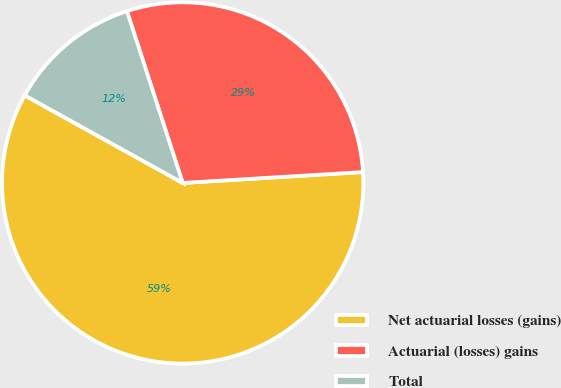Convert chart to OTSL. <chart><loc_0><loc_0><loc_500><loc_500><pie_chart><fcel>Net actuarial losses (gains)<fcel>Actuarial (losses) gains<fcel>Total<nl><fcel>59.02%<fcel>29.04%<fcel>11.95%<nl></chart> 